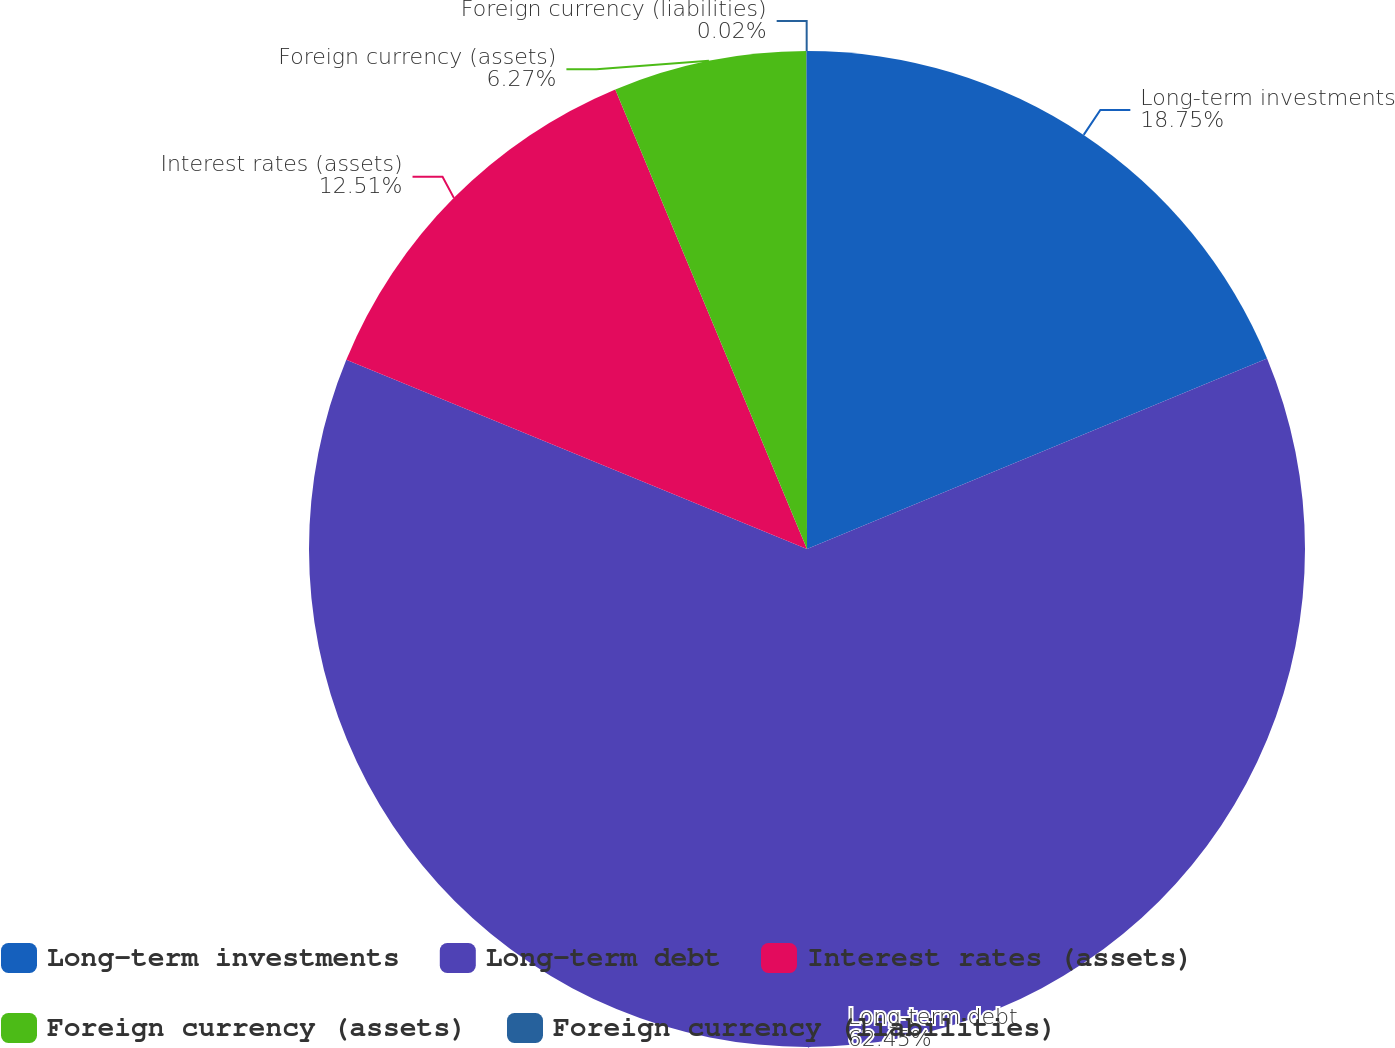Convert chart. <chart><loc_0><loc_0><loc_500><loc_500><pie_chart><fcel>Long-term investments<fcel>Long-term debt<fcel>Interest rates (assets)<fcel>Foreign currency (assets)<fcel>Foreign currency (liabilities)<nl><fcel>18.75%<fcel>62.45%<fcel>12.51%<fcel>6.27%<fcel>0.02%<nl></chart> 